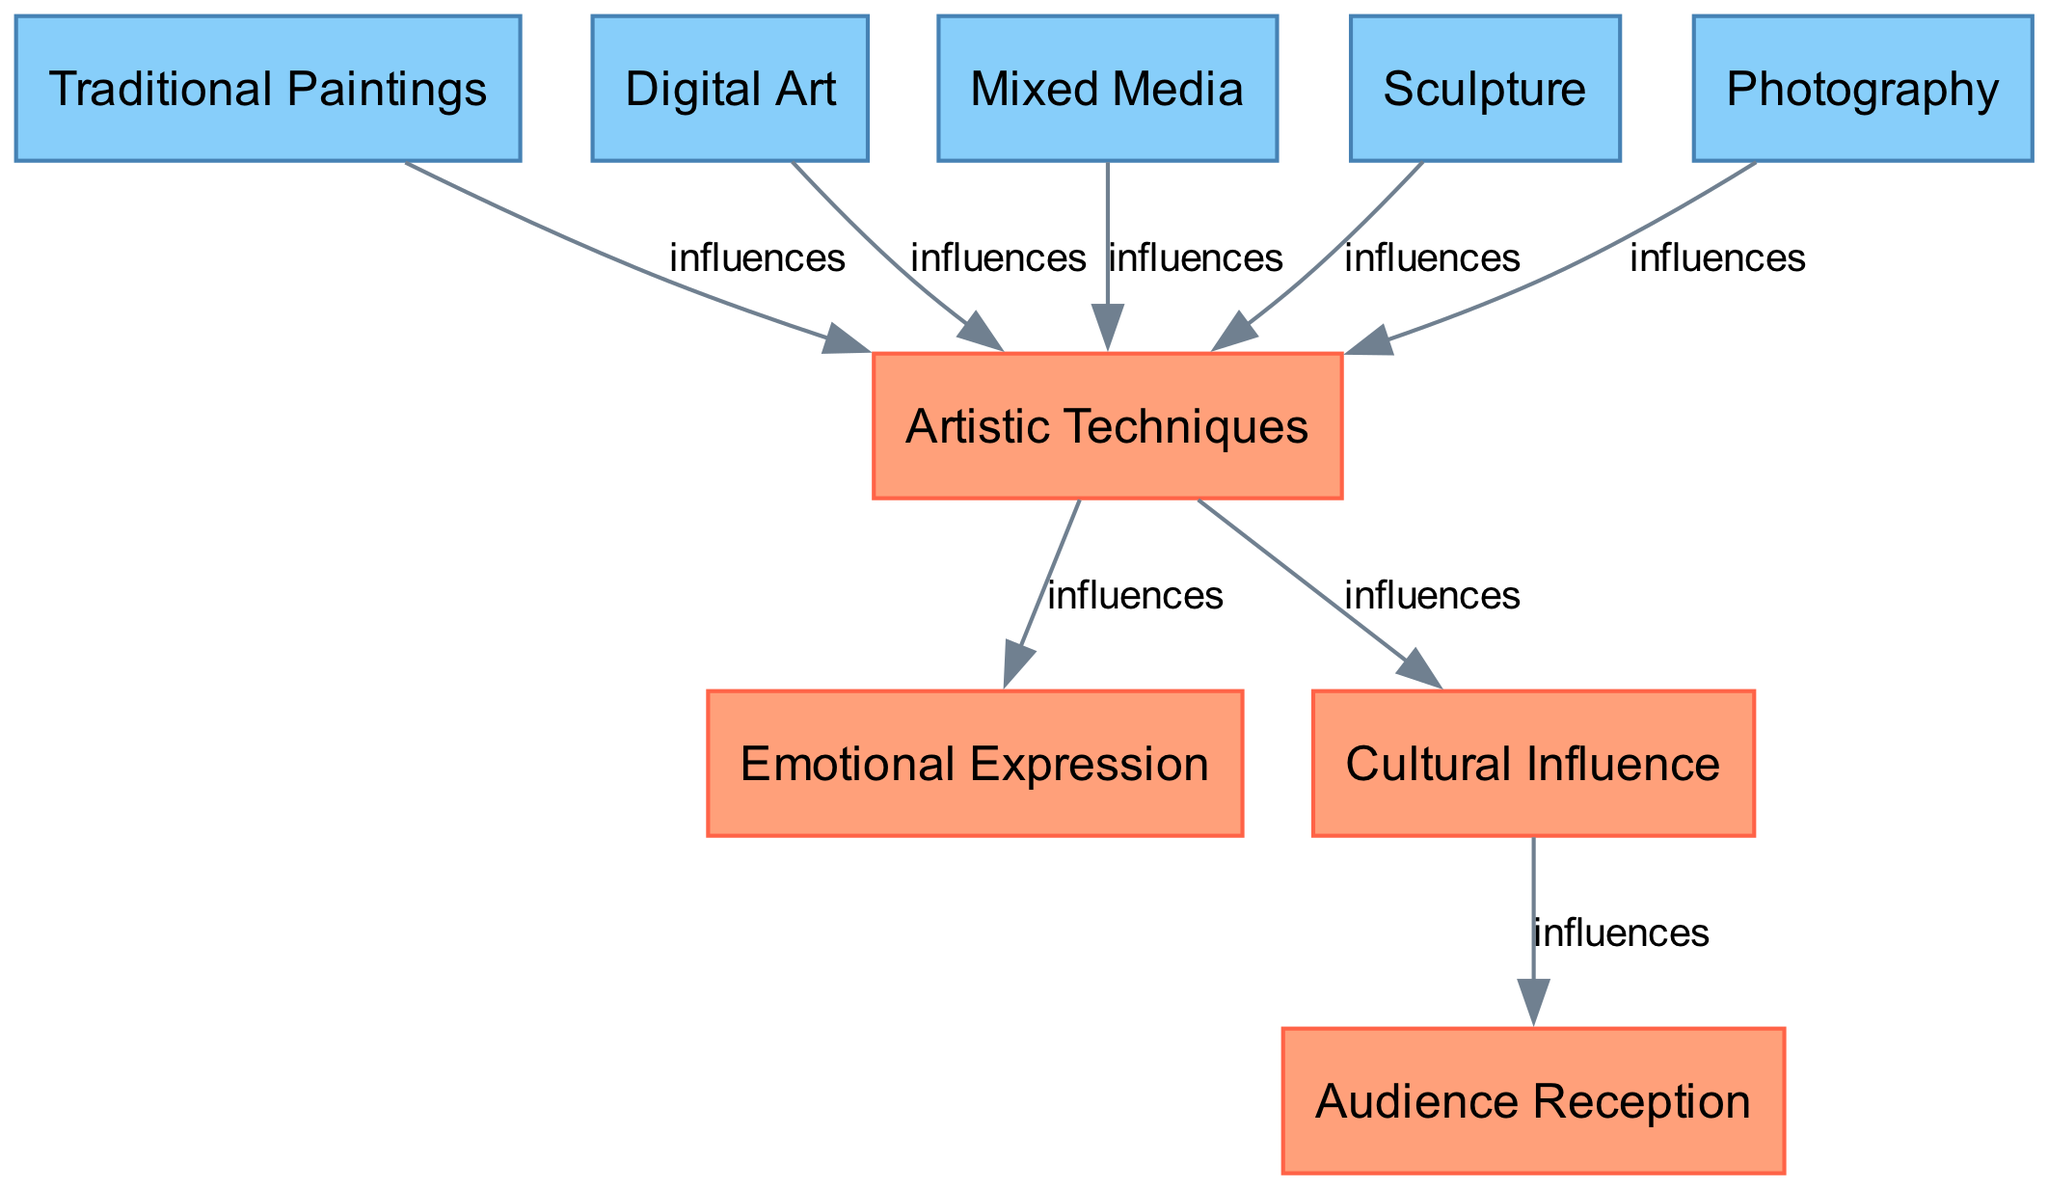What is the total number of nodes in the diagram? The diagram lists several nodes directly, including Traditional Paintings, Digital Art, Mixed Media, Sculpture, Photography, Artistic Techniques, Emotional Expression, Cultural Influence, and Audience Reception. Counting these, we find there are 9 distinct nodes in total.
Answer: 9 How many edges are present in the diagram? By analyzing the connections shown via edges, we can see there are multiple relationships described. Each connection between the source and target nodes represents an edge. Counting these gives us a total of 8 edges in the diagram.
Answer: 8 Which medium directly influences Emotional Expression? Looking at the edges, the node Artistic Techniques has a direct edge leading to Emotional Expression, indicating that the various artistic techniques can influence the emotional expression in art. Hence, the answer to the specific medium influencing Emotional Expression refers to Artistic Techniques, which encompasses various mediums.
Answer: Artistic Techniques What are the mediums that influence Artistic Techniques? The diagram shows multiple edges emanating from the nodes representing Traditional Paintings, Digital Art, Mixed Media, Sculpture, and Photography that connect to Artistic Techniques. These mediums collectively provide varying artistic techniques.
Answer: Traditional Paintings, Digital Art, Mixed Media, Sculpture, Photography Which node influences Audience Reception? Tracing the edges, we find that Cultural Influence has a direct edge that leads to Audience Reception. This shows that cultural elements help shape how art is received by an audience.
Answer: Cultural Influence How does Artistic Techniques affect Emotional Expression? The edge from Artistic Techniques to Emotional Expression signifies that artistic methods and styles can evoke or communicate emotions through art, establishing a relationship in this way.
Answer: Influences Which medium does not influence Emotional Expression directly? Considering the edges leading to Emotional Expression, we see that only Artistic Techniques connects to it. The mediums Traditional Paintings, Digital Art, Mixed Media, Sculpture, and Photography influence Artistic Techniques but not Emotional Expression directly. Thus, all of these mediums do not influence Emotional Expression directly.
Answer: Traditional Paintings, Digital Art, Mixed Media, Sculpture, Photography How many nodes influence Cultural Influence? Observing the diagram, the only node that has a direct connection to Cultural Influence is Artistic Techniques, meaning it is influenced solely by the techniques used in art.
Answer: 1 